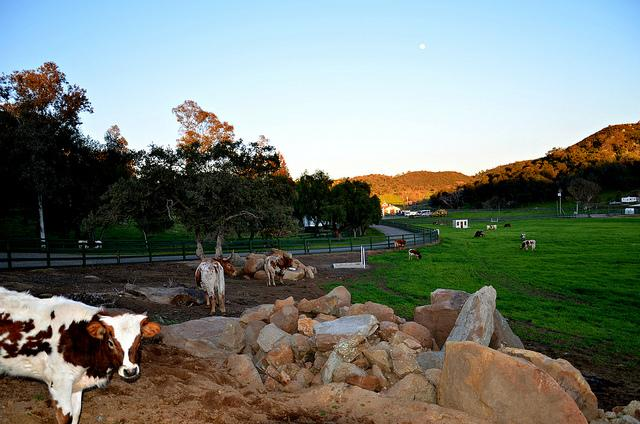What colors are on the cow closest to the camera? brown white 